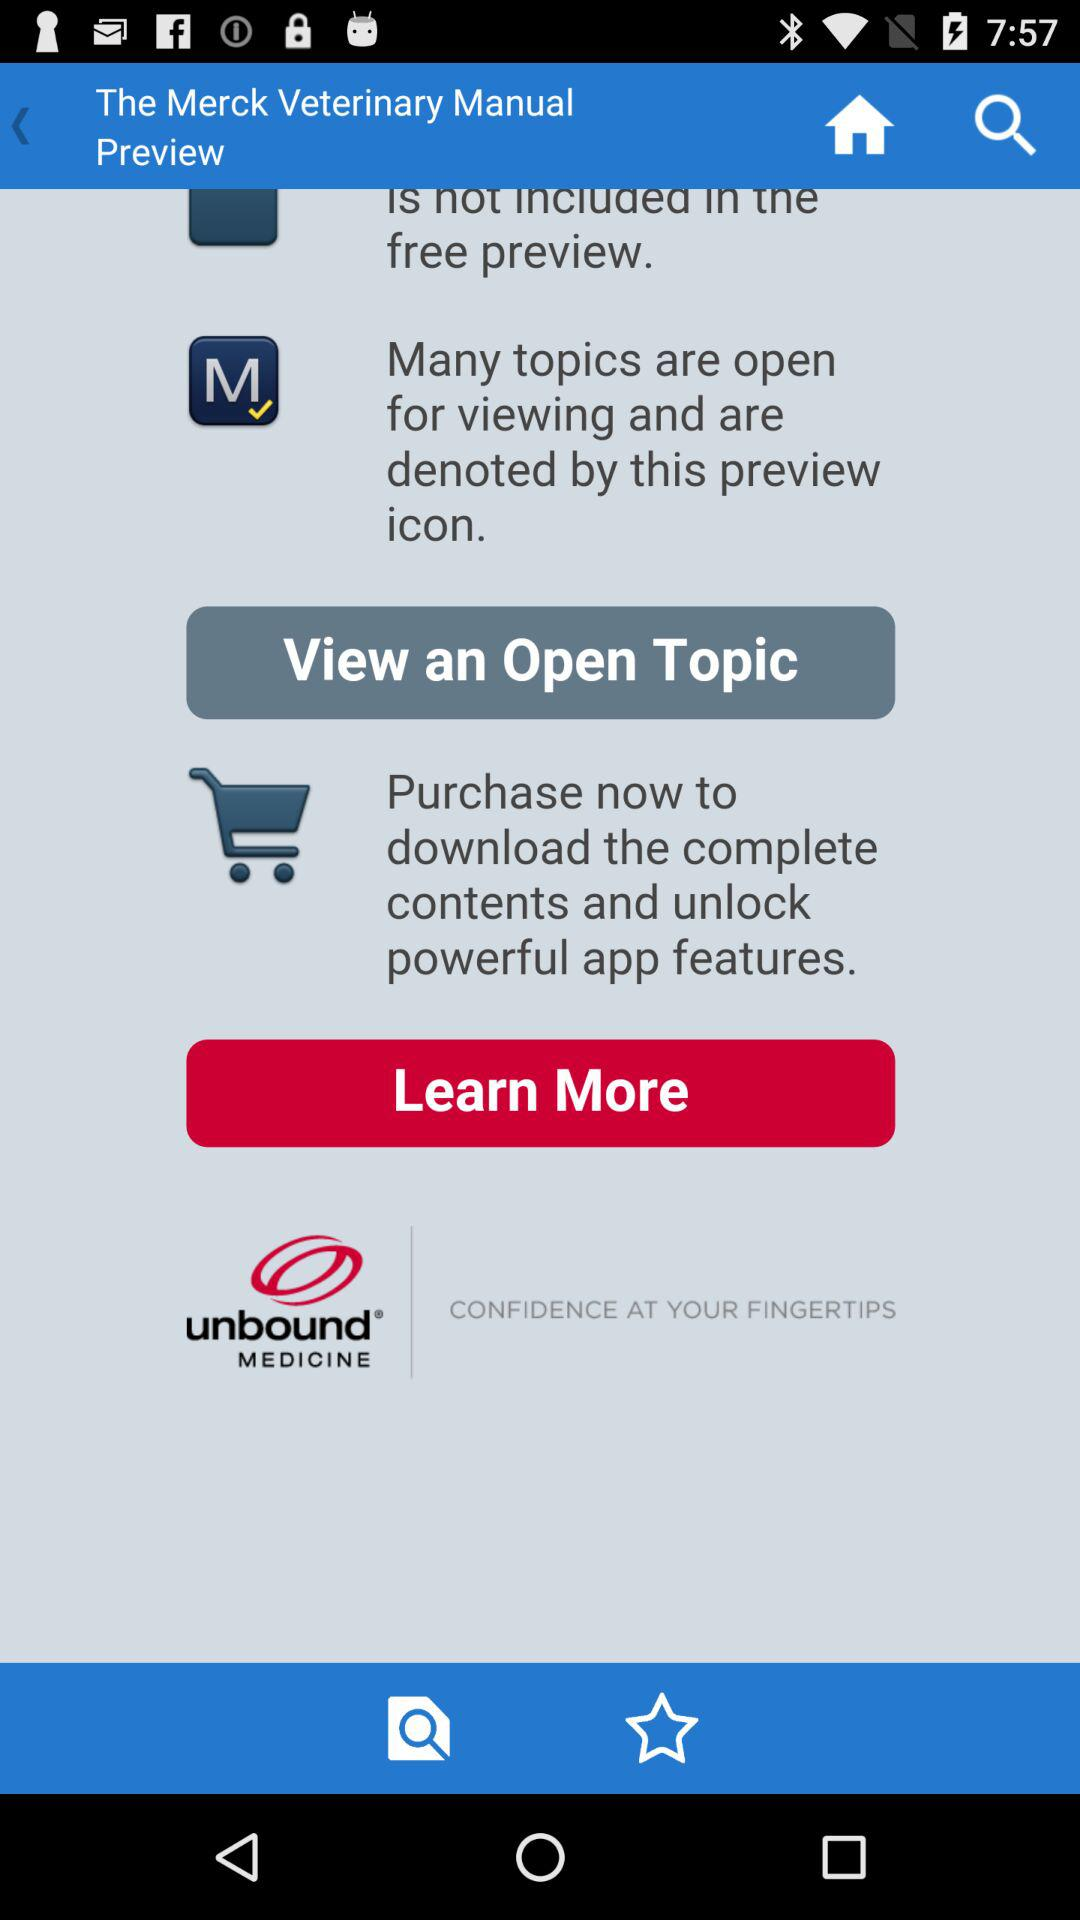What is the name of the application? The name of the application is "The Merck Veterinary Manual". 